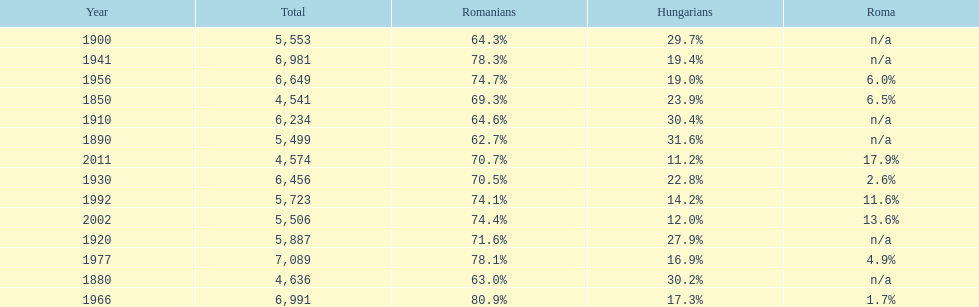Which year is previous to the year that had 74.1% in romanian population? 1977. 